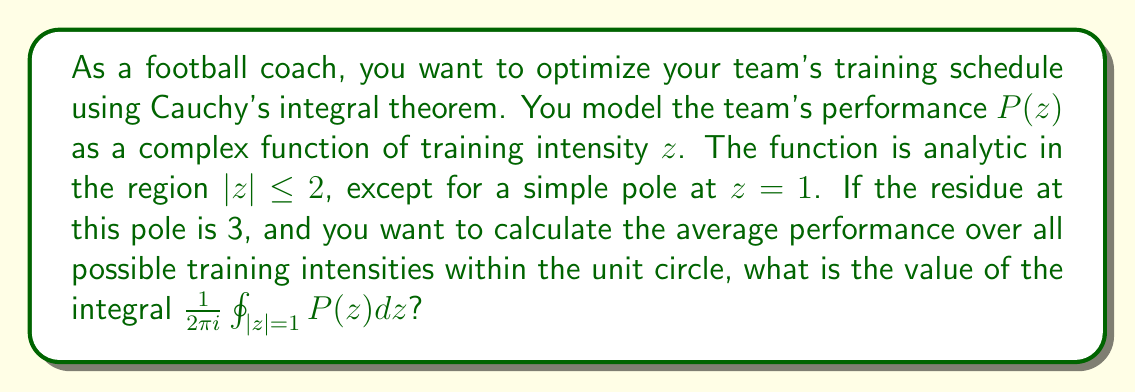Help me with this question. Let's approach this step-by-step using Cauchy's integral theorem:

1) The function $P(z)$ is analytic in the region $|z| \leq 2$, except for a simple pole at $z=1$.

2) The integral we need to calculate is:

   $$\frac{1}{2\pi i} \oint_{|z|=1} P(z) dz$$

3) This integral represents the average value of $P(z)$ over the unit circle.

4) According to Cauchy's residue theorem:

   $$\oint_{C} f(z) dz = 2\pi i \sum \text{Res}(f, a_k)$$

   where $a_k$ are the poles of $f(z)$ inside the contour $C$.

5) In our case, there's only one pole inside the unit circle, at $z=1$, and we're given that the residue at this pole is 3.

6) Therefore:

   $$\oint_{|z|=1} P(z) dz = 2\pi i \cdot 3 = 6\pi i$$

7) Dividing both sides by $2\pi i$:

   $$\frac{1}{2\pi i} \oint_{|z|=1} P(z) dz = \frac{6\pi i}{2\pi i} = 3$$

Thus, the average performance over all possible training intensities within the unit circle is 3.
Answer: 3 